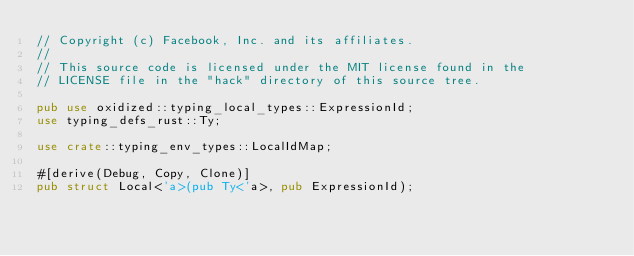<code> <loc_0><loc_0><loc_500><loc_500><_Rust_>// Copyright (c) Facebook, Inc. and its affiliates.
//
// This source code is licensed under the MIT license found in the
// LICENSE file in the "hack" directory of this source tree.

pub use oxidized::typing_local_types::ExpressionId;
use typing_defs_rust::Ty;

use crate::typing_env_types::LocalIdMap;

#[derive(Debug, Copy, Clone)]
pub struct Local<'a>(pub Ty<'a>, pub ExpressionId);
</code> 